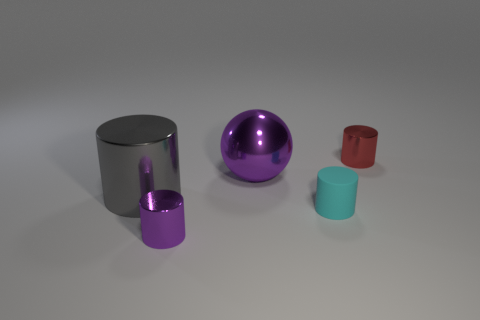Is there any other thing that is the same size as the gray metallic cylinder?
Give a very brief answer. Yes. Is the number of cylinders to the left of the tiny cyan matte cylinder less than the number of tiny blue metallic cylinders?
Your answer should be very brief. No. Is the large purple shiny object the same shape as the large gray metallic thing?
Your response must be concise. No. There is a big thing that is the same shape as the small matte object; what color is it?
Your answer should be very brief. Gray. How many small matte objects are the same color as the rubber cylinder?
Make the answer very short. 0. What number of objects are big metallic things behind the big shiny cylinder or large things?
Ensure brevity in your answer.  2. What is the size of the cylinder to the left of the purple cylinder?
Provide a succinct answer. Large. Is the number of cylinders less than the number of large cyan cubes?
Provide a succinct answer. No. Do the thing that is behind the big purple ball and the small object on the left side of the big metallic ball have the same material?
Provide a succinct answer. Yes. There is a large object that is to the left of the tiny metallic object that is on the left side of the small thing behind the big gray object; what is its shape?
Offer a terse response. Cylinder. 